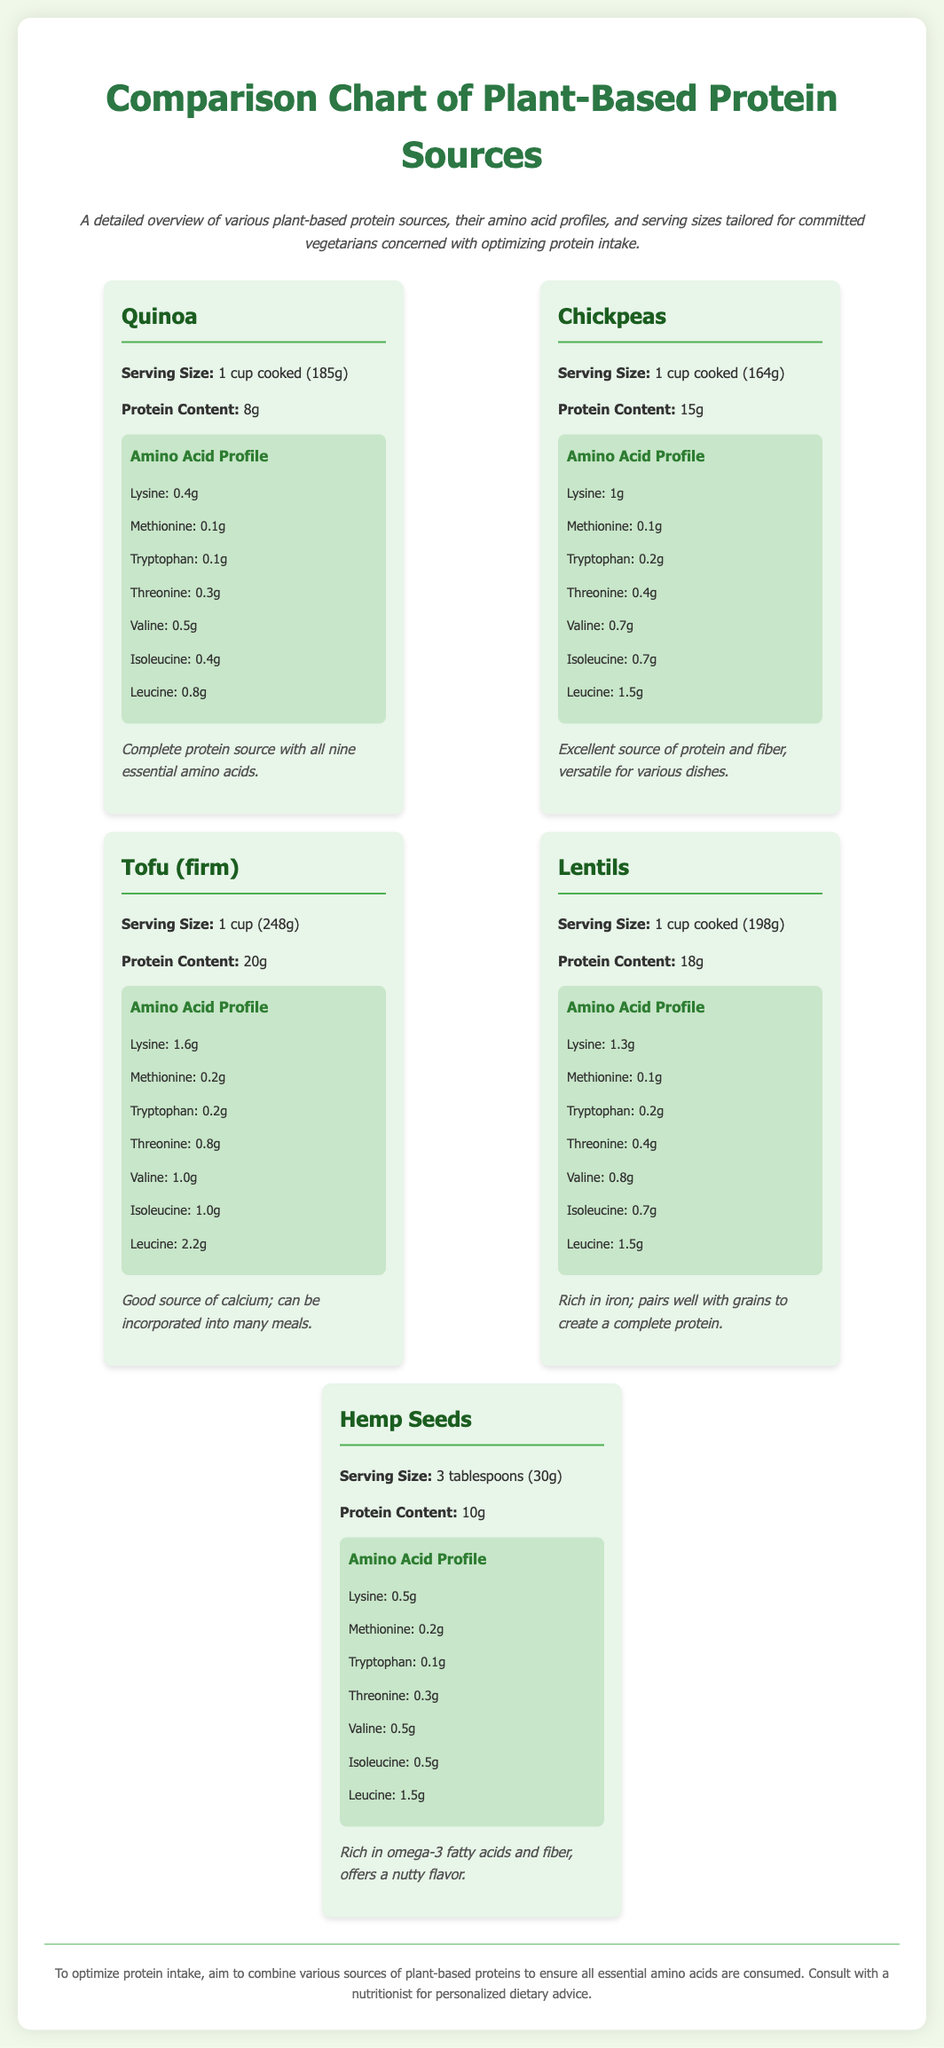what is the protein content of quinoa? The protein content of quinoa, as mentioned in the document, is 8g per serving.
Answer: 8g what is the serving size for chickpeas? The serving size for chickpeas is detailed in the document as 1 cup cooked, which weighs 164g.
Answer: 1 cup cooked (164g) how much protein do hemp seeds provide? The document states that hemp seeds provide 10g of protein per serving.
Answer: 10g which plant-based protein source has the highest protein content? According to the document, tofu (firm) has the highest protein content at 20g per serving.
Answer: Tofu (firm) what is the amino acid profile of lentils for lysine? The document specifies that lentils have 1.3g of lysine per serving.
Answer: 1.3g which protein source is described as a complete protein? The document mentions that quinoa is a complete protein source with all nine essential amino acids.
Answer: Quinoa what essential nutrient do hemp seeds provide aside from protein? The document notes that hemp seeds are rich in omega-3 fatty acids.
Answer: Omega-3 fatty acids how many grams of protein are in lentils? The protein content for lentils, as listed in the document, is 18g per serving.
Answer: 18g what additional benefit does tofu provide? The document indicates that tofu is a good source of calcium.
Answer: Calcium 